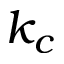Convert formula to latex. <formula><loc_0><loc_0><loc_500><loc_500>k _ { c }</formula> 